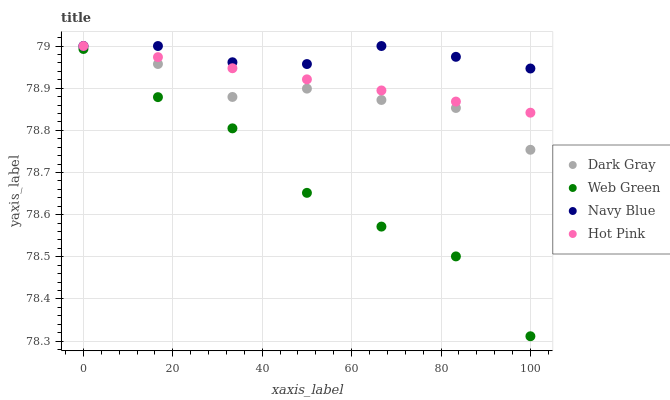Does Web Green have the minimum area under the curve?
Answer yes or no. Yes. Does Navy Blue have the maximum area under the curve?
Answer yes or no. Yes. Does Hot Pink have the minimum area under the curve?
Answer yes or no. No. Does Hot Pink have the maximum area under the curve?
Answer yes or no. No. Is Hot Pink the smoothest?
Answer yes or no. Yes. Is Web Green the roughest?
Answer yes or no. Yes. Is Navy Blue the smoothest?
Answer yes or no. No. Is Navy Blue the roughest?
Answer yes or no. No. Does Web Green have the lowest value?
Answer yes or no. Yes. Does Hot Pink have the lowest value?
Answer yes or no. No. Does Hot Pink have the highest value?
Answer yes or no. Yes. Does Web Green have the highest value?
Answer yes or no. No. Is Web Green less than Navy Blue?
Answer yes or no. Yes. Is Dark Gray greater than Web Green?
Answer yes or no. Yes. Does Navy Blue intersect Hot Pink?
Answer yes or no. Yes. Is Navy Blue less than Hot Pink?
Answer yes or no. No. Is Navy Blue greater than Hot Pink?
Answer yes or no. No. Does Web Green intersect Navy Blue?
Answer yes or no. No. 